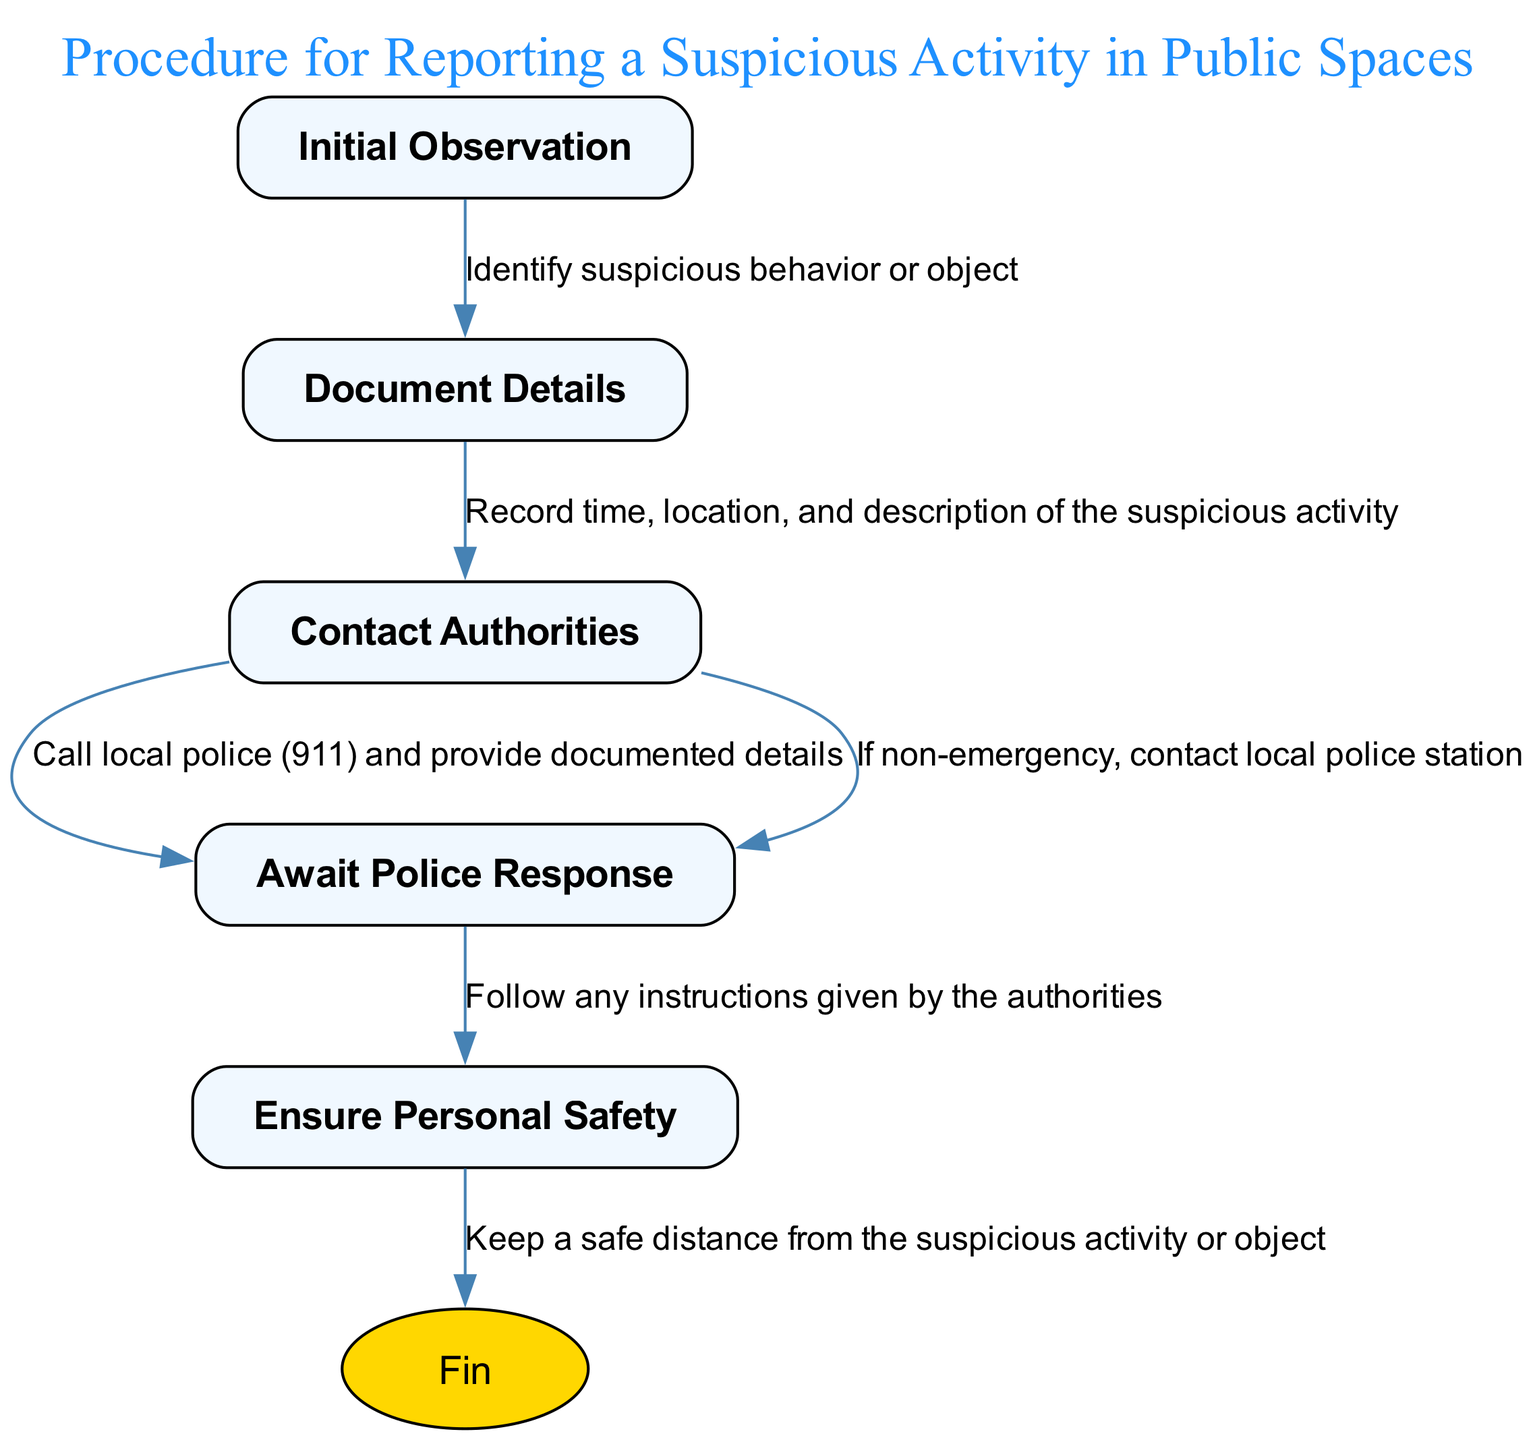What is the first step in the procedure? The first step is "Initial Observation," which involves identifying suspicious behavior or object.
Answer: Initial Observation How many total steps are there in this procedure? The diagram contains five main steps: Initial Observation, Document Details, Contact Authorities, Await Police Response, and Ensure Personal Safety.
Answer: Five What do you need to document in the second step? In the second step, you need to record the time, location, and description of the suspicious activity.
Answer: Time, location, and description What is the action taken in the "Contact Authorities" step if it's a non-emergency? If it's a non-emergency, the action taken is to contact the local police station.
Answer: Contact local police station What should you do while awaiting police response? While awaiting police response, you should follow any instructions given by the authorities.
Answer: Follow instructions What is the last action in the procedure? The last action is to keep a safe distance from the suspicious activity or object, ensuring personal safety.
Answer: Keep a safe distance What flows from "Document Details" to the next step? The action that flows from "Document Details" is to call the police and provide documented details.
Answer: Call police and provide details Which step directly follows "Await Police Response"? The step that directly follows "Await Police Response" is "Ensure Personal Safety."
Answer: Ensure Personal Safety 